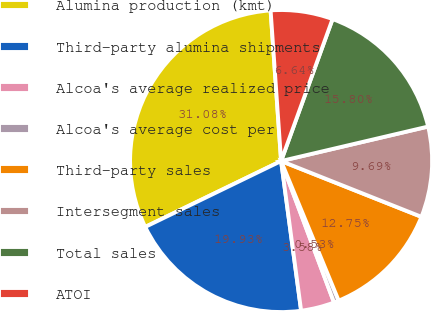<chart> <loc_0><loc_0><loc_500><loc_500><pie_chart><fcel>Alumina production (kmt)<fcel>Third-party alumina shipments<fcel>Alcoa's average realized price<fcel>Alcoa's average cost per<fcel>Third-party sales<fcel>Intersegment sales<fcel>Total sales<fcel>ATOI<nl><fcel>31.08%<fcel>19.93%<fcel>3.58%<fcel>0.53%<fcel>12.75%<fcel>9.69%<fcel>15.8%<fcel>6.64%<nl></chart> 